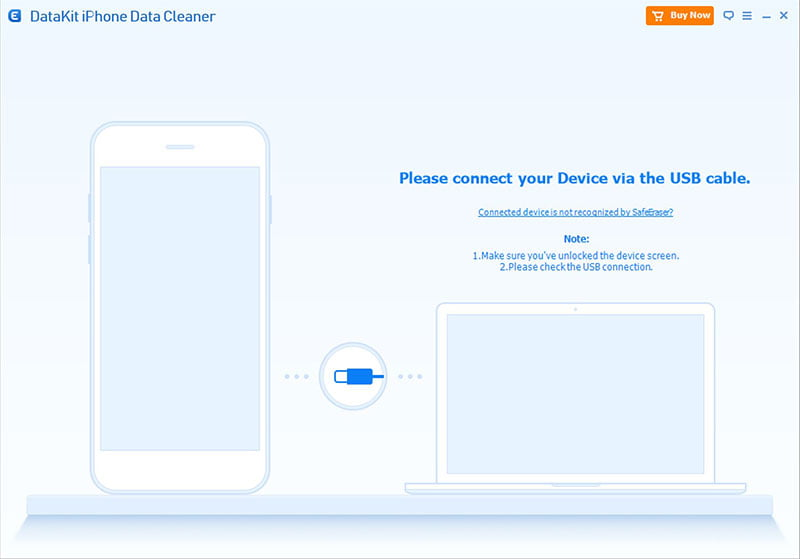What troubleshooting tips does the interface provide for a user experiencing connection issues? The interface offers two main troubleshooting tips for users facing connection issues. Firstly, it suggests ensuring the device screen is unlocked. This is likely because the software requires access to the unlocked device to establish a connection properly. Secondly, it advises the user to verify the USB connection, which involves checking that the cable is correctly plugged into both the computer and the phone, and ensuring that the right USB cable is being used. Additionally, there is a clickable question, 'Connected device is not recognized by SafeEraser?' which may provide further detailed assistance if clicked. 